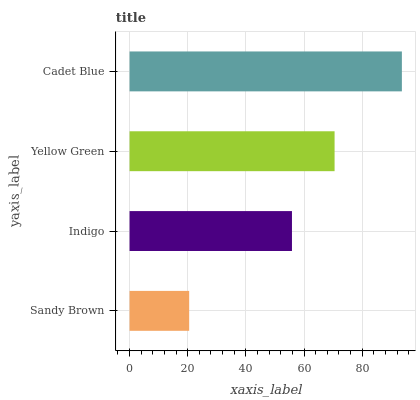Is Sandy Brown the minimum?
Answer yes or no. Yes. Is Cadet Blue the maximum?
Answer yes or no. Yes. Is Indigo the minimum?
Answer yes or no. No. Is Indigo the maximum?
Answer yes or no. No. Is Indigo greater than Sandy Brown?
Answer yes or no. Yes. Is Sandy Brown less than Indigo?
Answer yes or no. Yes. Is Sandy Brown greater than Indigo?
Answer yes or no. No. Is Indigo less than Sandy Brown?
Answer yes or no. No. Is Yellow Green the high median?
Answer yes or no. Yes. Is Indigo the low median?
Answer yes or no. Yes. Is Cadet Blue the high median?
Answer yes or no. No. Is Yellow Green the low median?
Answer yes or no. No. 